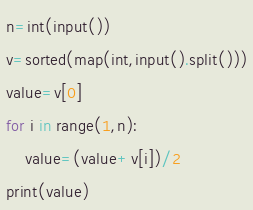Convert code to text. <code><loc_0><loc_0><loc_500><loc_500><_Python_>n=int(input())
v=sorted(map(int,input().split()))
value=v[0]
for i in range(1,n):
    value=(value+v[i])/2
print(value)</code> 